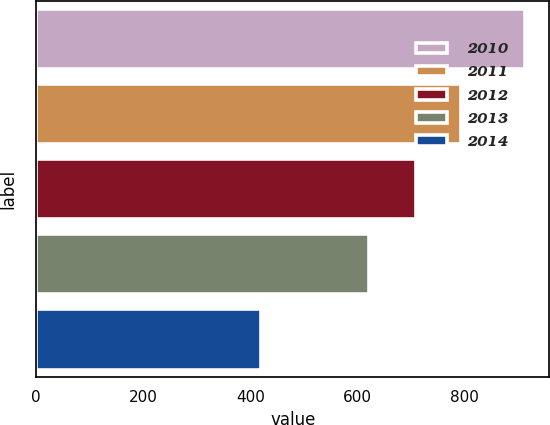<chart> <loc_0><loc_0><loc_500><loc_500><bar_chart><fcel>2010<fcel>2011<fcel>2012<fcel>2013<fcel>2014<nl><fcel>913<fcel>793<fcel>710<fcel>621<fcel>420<nl></chart> 